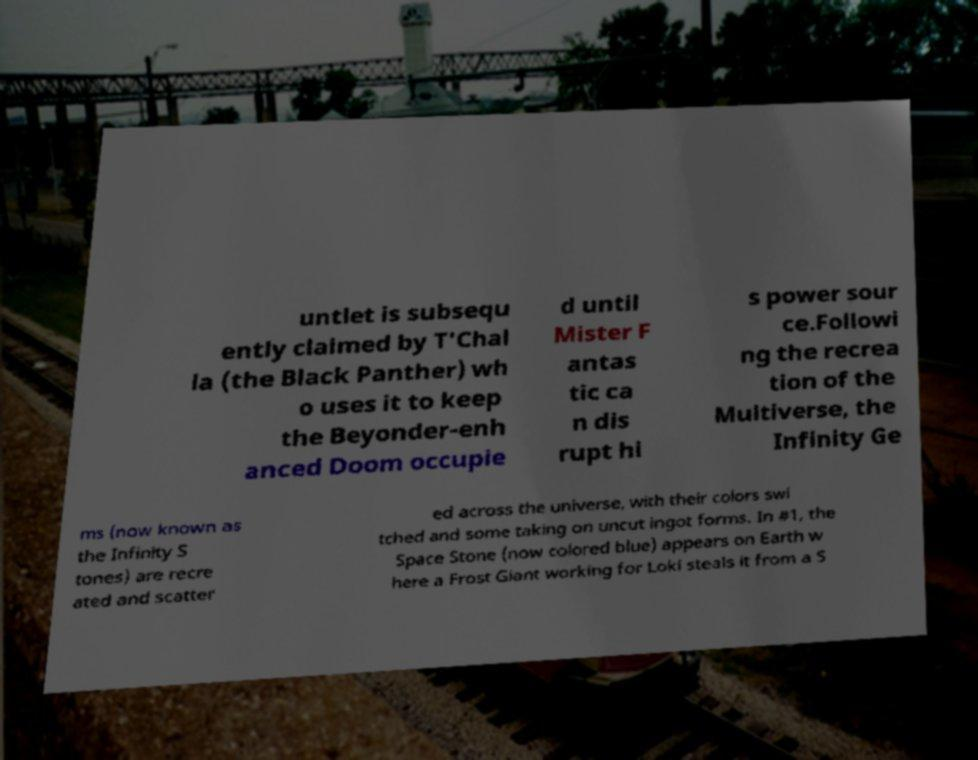Could you assist in decoding the text presented in this image and type it out clearly? untlet is subsequ ently claimed by T'Chal la (the Black Panther) wh o uses it to keep the Beyonder-enh anced Doom occupie d until Mister F antas tic ca n dis rupt hi s power sour ce.Followi ng the recrea tion of the Multiverse, the Infinity Ge ms (now known as the Infinity S tones) are recre ated and scatter ed across the universe, with their colors swi tched and some taking on uncut ingot forms. In #1, the Space Stone (now colored blue) appears on Earth w here a Frost Giant working for Loki steals it from a S 